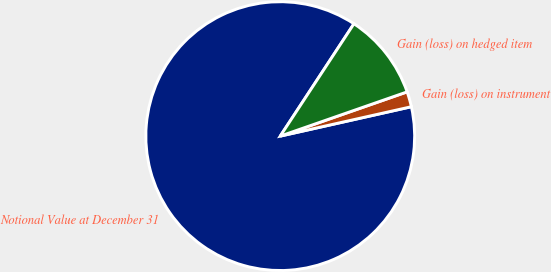Convert chart. <chart><loc_0><loc_0><loc_500><loc_500><pie_chart><fcel>Notional Value at December 31<fcel>Gain (loss) on instrument<fcel>Gain (loss) on hedged item<nl><fcel>87.75%<fcel>1.83%<fcel>10.42%<nl></chart> 